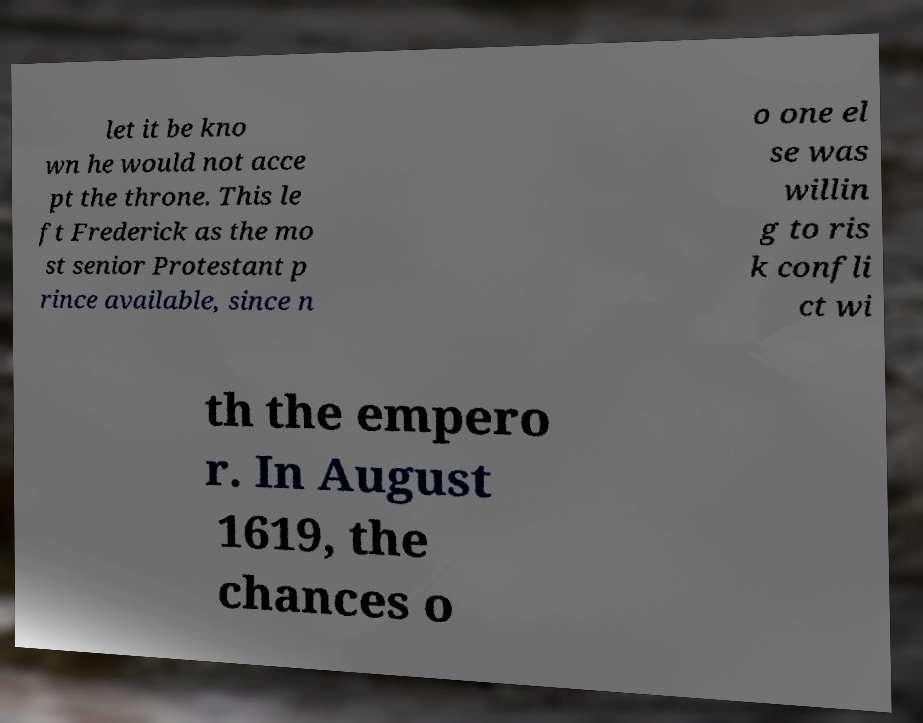What messages or text are displayed in this image? I need them in a readable, typed format. let it be kno wn he would not acce pt the throne. This le ft Frederick as the mo st senior Protestant p rince available, since n o one el se was willin g to ris k confli ct wi th the empero r. In August 1619, the chances o 